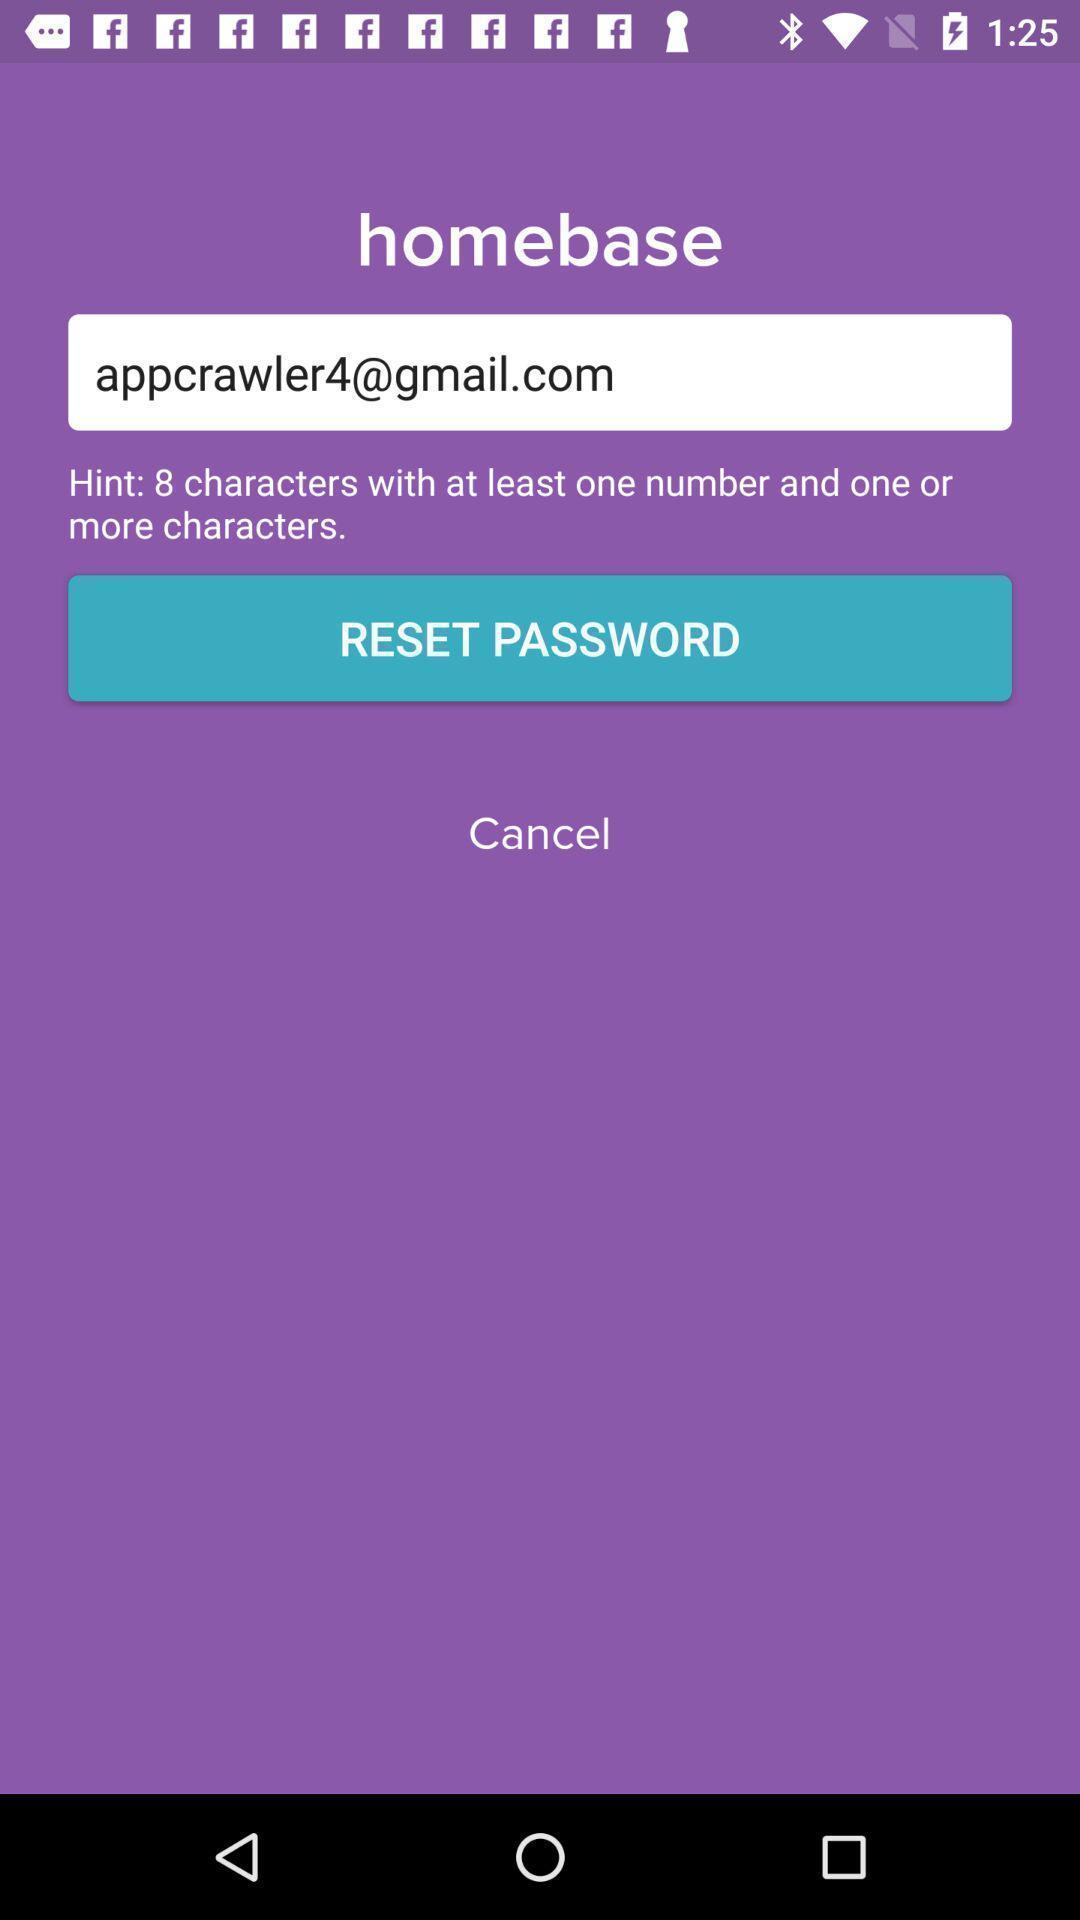Tell me about the visual elements in this screen capture. Page displaying to reset password. 